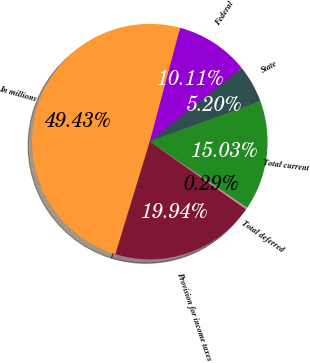<chart> <loc_0><loc_0><loc_500><loc_500><pie_chart><fcel>In millions<fcel>Federal<fcel>State<fcel>Total current<fcel>Total deferred<fcel>Provision for income taxes<nl><fcel>49.43%<fcel>10.11%<fcel>5.2%<fcel>15.03%<fcel>0.29%<fcel>19.94%<nl></chart> 